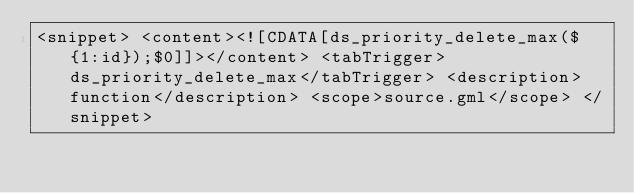Convert code to text. <code><loc_0><loc_0><loc_500><loc_500><_XML_><snippet> <content><![CDATA[ds_priority_delete_max(${1:id});$0]]></content> <tabTrigger>ds_priority_delete_max</tabTrigger> <description>function</description> <scope>source.gml</scope> </snippet> 
</code> 